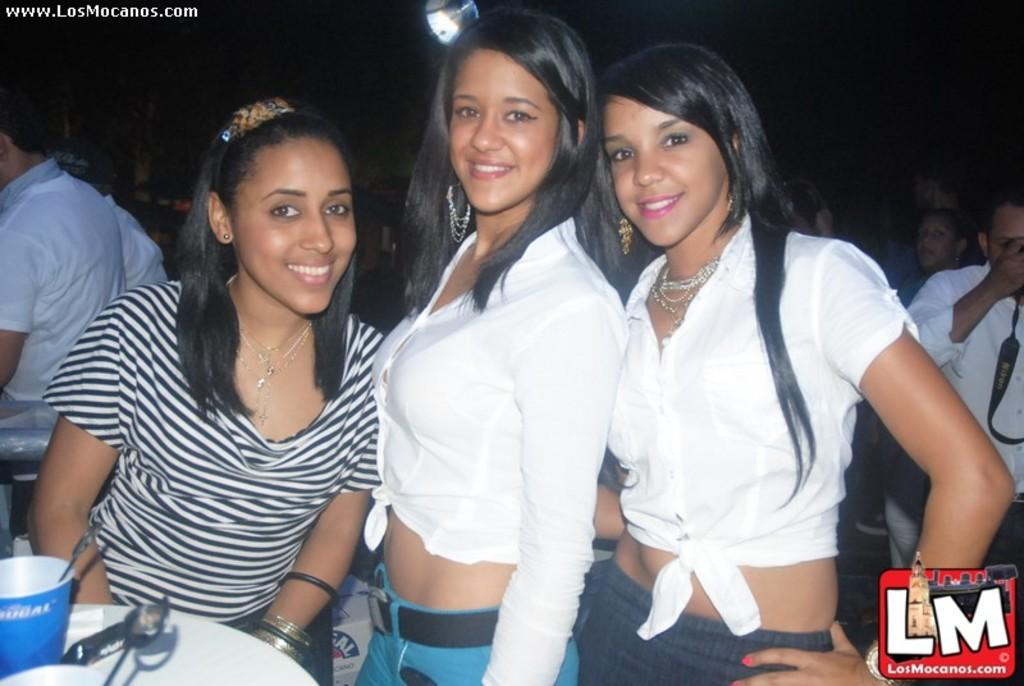Provide a one-sentence caption for the provided image. Three women sit at a table for a picture and it has LM on the lower right corner. 